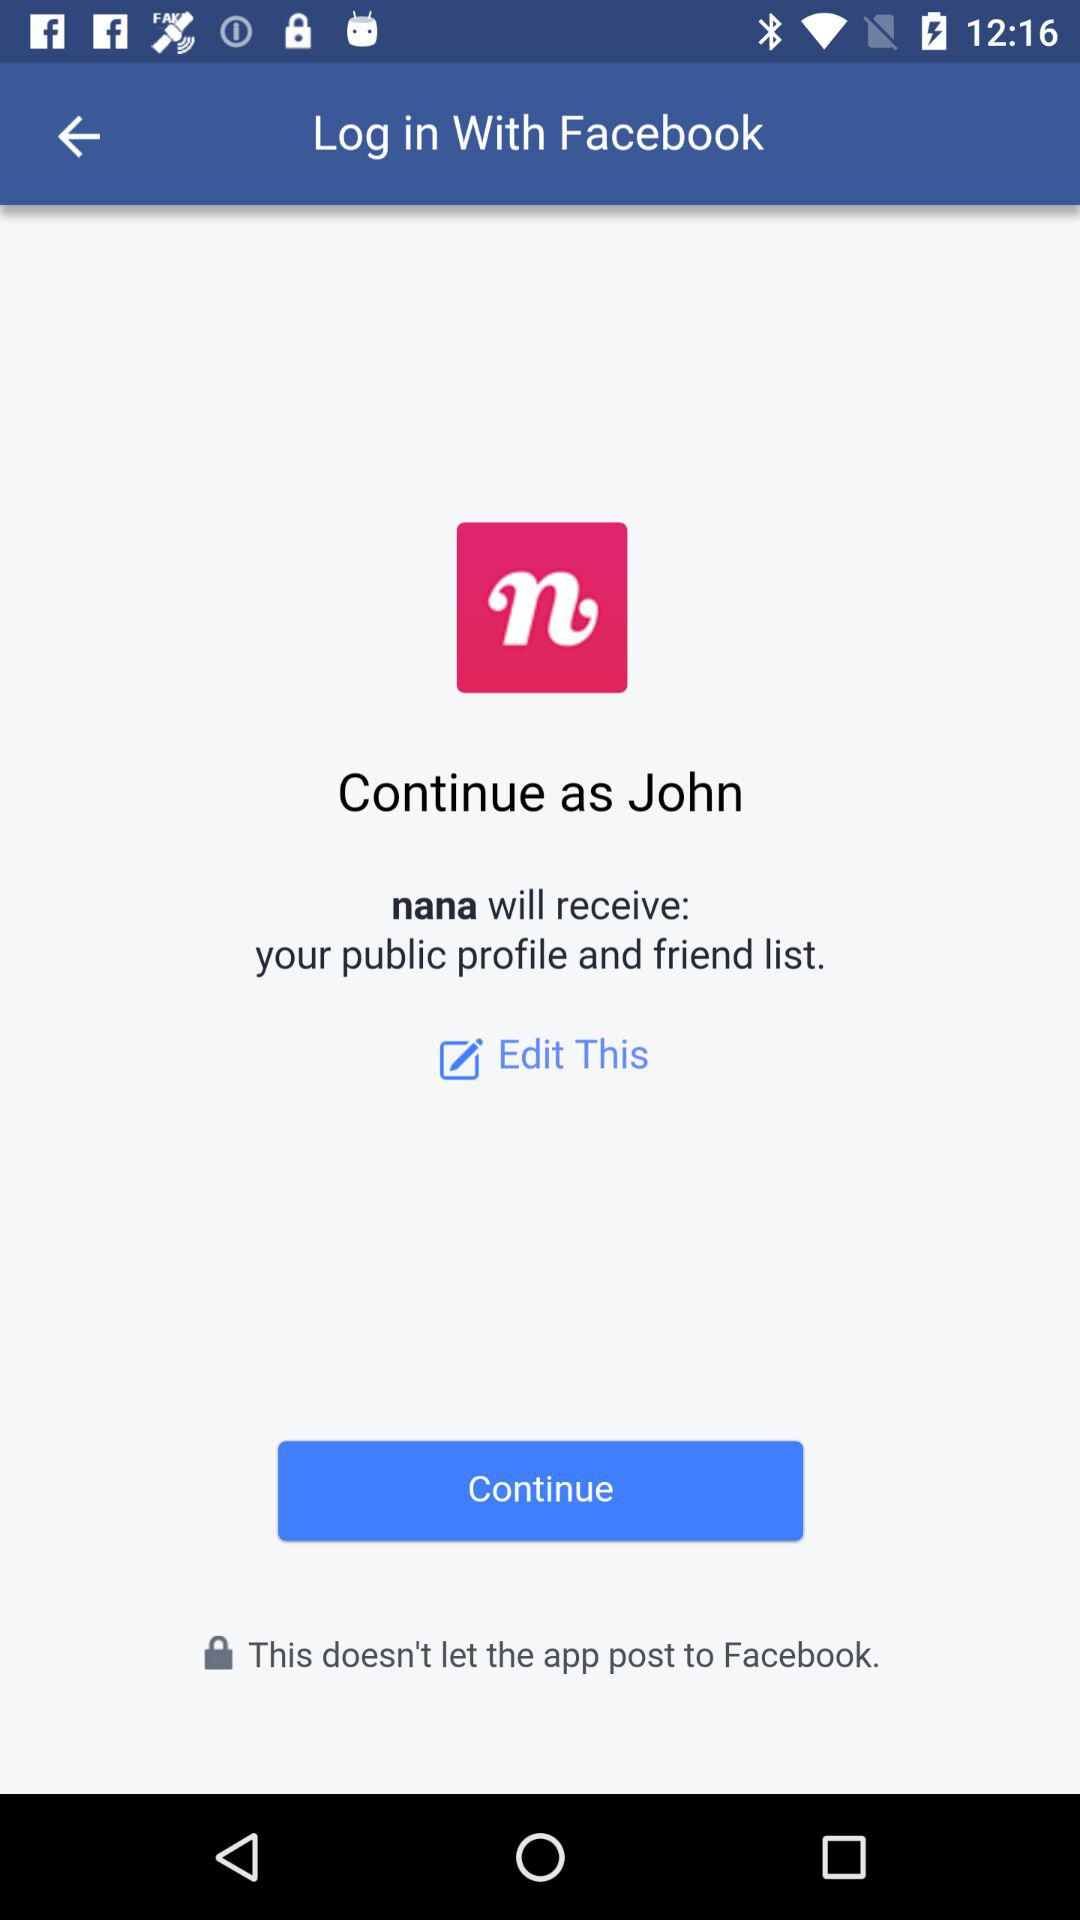What application is asking for permission? The application is "nana". 